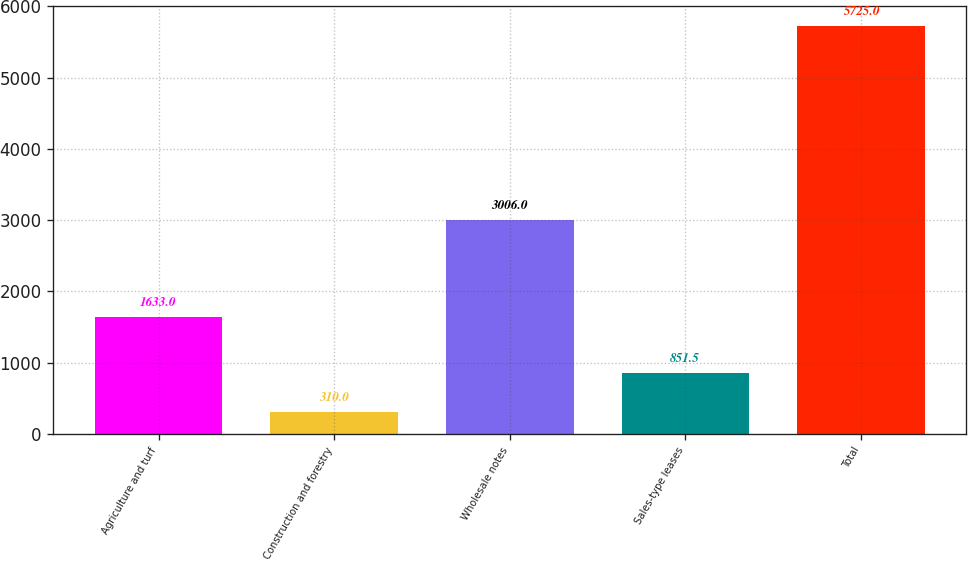Convert chart. <chart><loc_0><loc_0><loc_500><loc_500><bar_chart><fcel>Agriculture and turf<fcel>Construction and forestry<fcel>Wholesale notes<fcel>Sales-type leases<fcel>Total<nl><fcel>1633<fcel>310<fcel>3006<fcel>851.5<fcel>5725<nl></chart> 